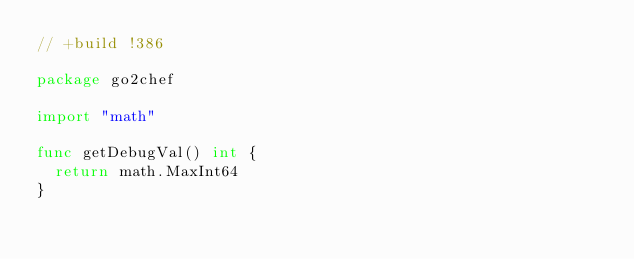<code> <loc_0><loc_0><loc_500><loc_500><_Go_>// +build !386

package go2chef

import "math"

func getDebugVal() int {
	return math.MaxInt64
}
</code> 